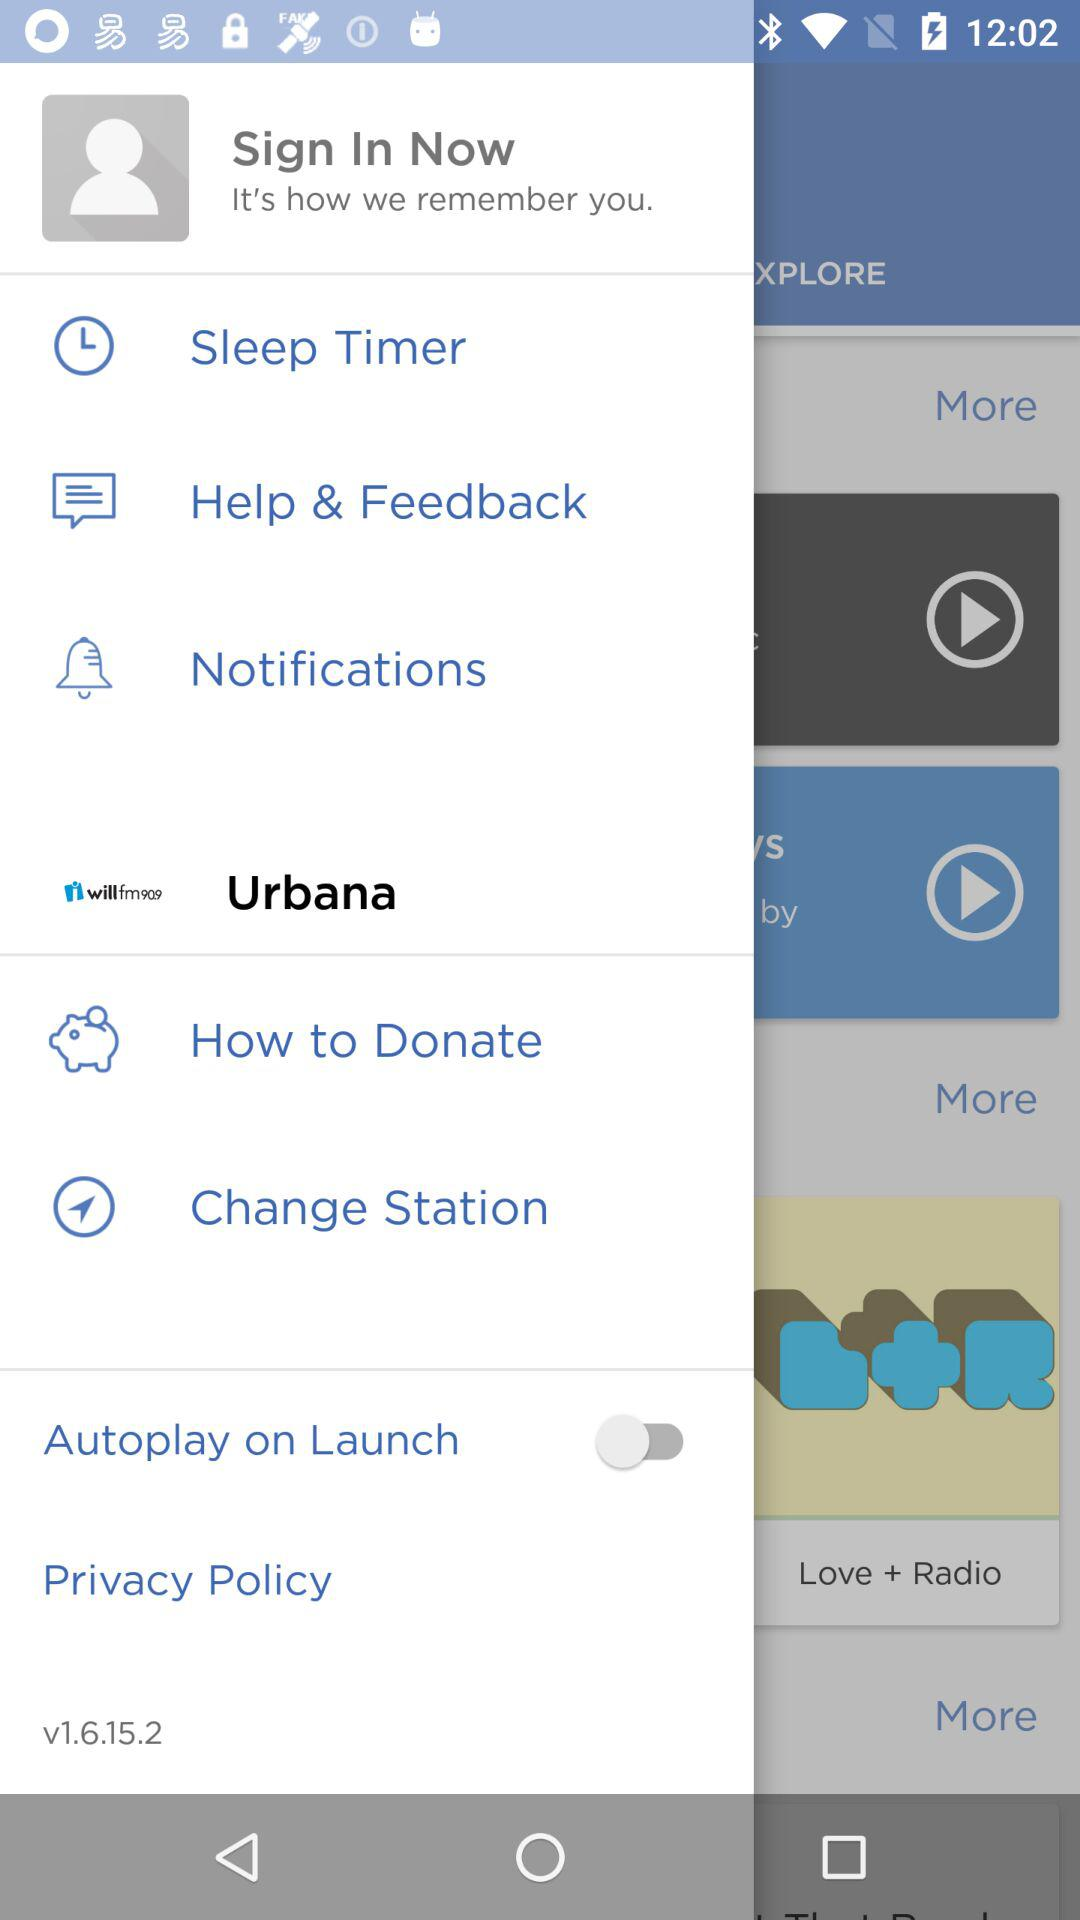What is the city name? The city name is Urbana. 